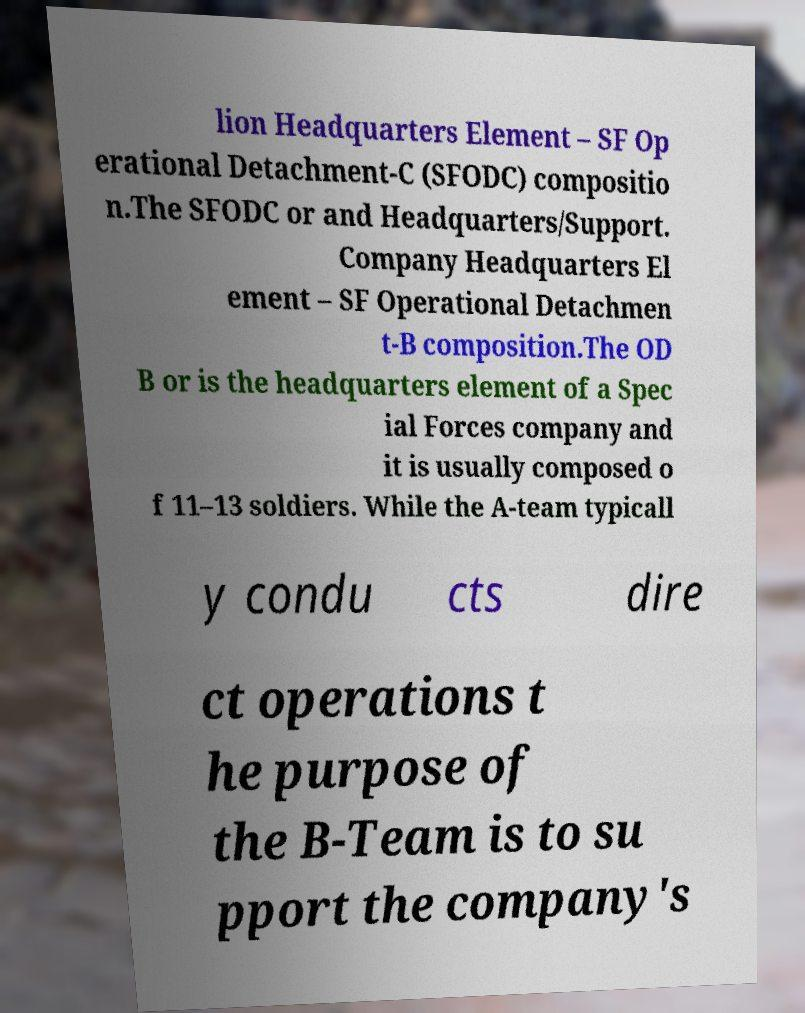Could you extract and type out the text from this image? lion Headquarters Element – SF Op erational Detachment-C (SFODC) compositio n.The SFODC or and Headquarters/Support. Company Headquarters El ement – SF Operational Detachmen t-B composition.The OD B or is the headquarters element of a Spec ial Forces company and it is usually composed o f 11–13 soldiers. While the A-team typicall y condu cts dire ct operations t he purpose of the B-Team is to su pport the company's 